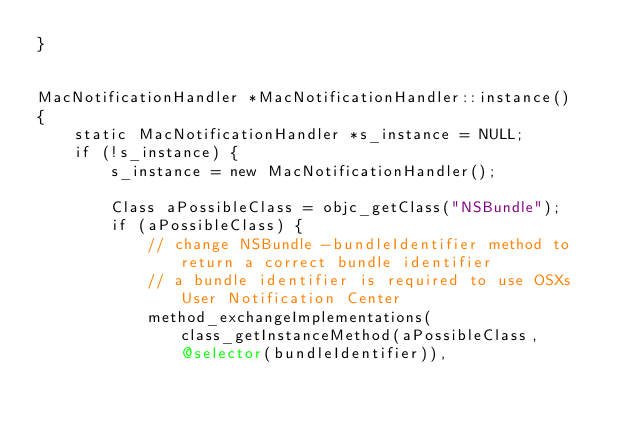Convert code to text. <code><loc_0><loc_0><loc_500><loc_500><_ObjectiveC_>}


MacNotificationHandler *MacNotificationHandler::instance()
{
    static MacNotificationHandler *s_instance = NULL;
    if (!s_instance) {
        s_instance = new MacNotificationHandler();
        
        Class aPossibleClass = objc_getClass("NSBundle");
        if (aPossibleClass) {
            // change NSBundle -bundleIdentifier method to return a correct bundle identifier
            // a bundle identifier is required to use OSXs User Notification Center
            method_exchangeImplementations(class_getInstanceMethod(aPossibleClass, @selector(bundleIdentifier)),</code> 